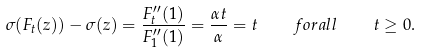<formula> <loc_0><loc_0><loc_500><loc_500>\sigma ( F _ { t } ( z ) ) - \sigma ( z ) = \frac { F ^ { \prime \prime } _ { t } ( 1 ) } { F ^ { \prime \prime } _ { 1 } ( 1 ) } = \frac { \alpha t } { \alpha } = t \quad f o r a l l \quad t \geq 0 .</formula> 